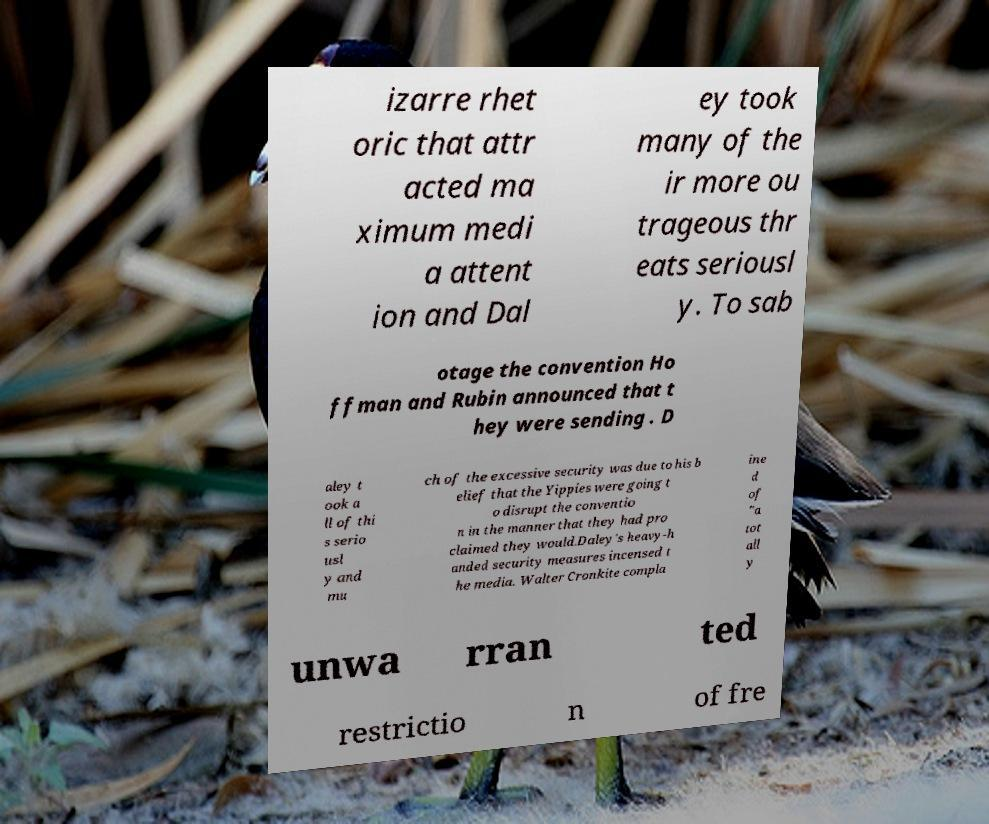Could you extract and type out the text from this image? izarre rhet oric that attr acted ma ximum medi a attent ion and Dal ey took many of the ir more ou trageous thr eats seriousl y. To sab otage the convention Ho ffman and Rubin announced that t hey were sending . D aley t ook a ll of thi s serio usl y and mu ch of the excessive security was due to his b elief that the Yippies were going t o disrupt the conventio n in the manner that they had pro claimed they would.Daley's heavy-h anded security measures incensed t he media. Walter Cronkite compla ine d of "a tot all y unwa rran ted restrictio n of fre 